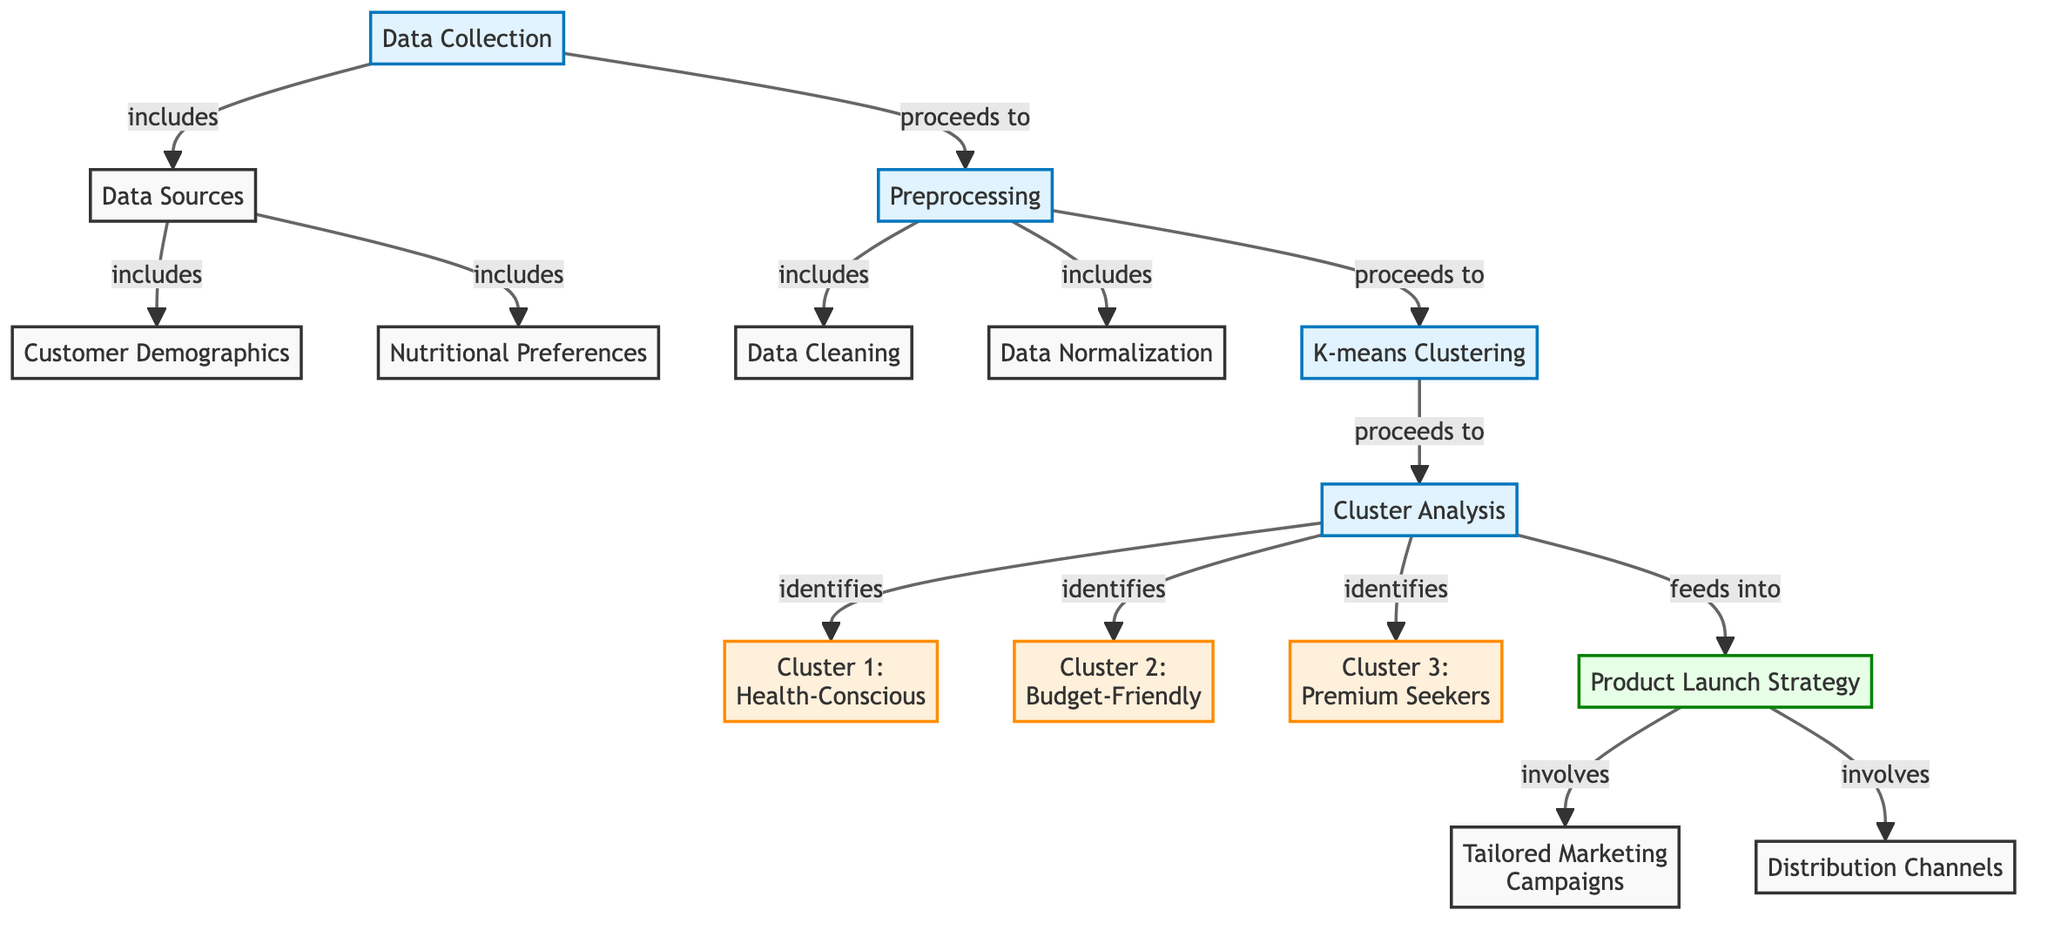What is the initial step in the process? The initial step in the process as represented in the diagram is "Data Collection." This is indicated by the first node in the flowchart and serves as the starting point for the analysis.
Answer: Data Collection How many clusters are identified in the cluster analysis? The diagram indicates three clusters identified during the cluster analysis: Cluster 1, Cluster 2, and Cluster 3. This is summarized in the nodes connected to the cluster analysis step.
Answer: 3 What is the outcome of k-means clustering? The outcome of k-means clustering is "Cluster Analysis." This is shown as the next step that follows k-means clustering in the flowchart.
Answer: Cluster Analysis Which cluster is categorized as 'Premium Seekers'? "Cluster 3" is categorized as 'Premium Seekers' according to the labeled node in the diagram. The node specifically identifies this segment of the market.
Answer: Cluster 3: Premium Seekers What follows the product launch strategy in the diagram? Following the product launch strategy are "Tailored Marketing Campaigns" and "Distribution Channels." These are both shown as subsequent aspects involved in the strategy.
Answer: Tailored Marketing Campaigns, Distribution Channels How is data collected in the initial step? Data is collected from two sources: "Customer Demographics" and "Nutritional Preferences." These sources are indicated as outputs of the data collection process.
Answer: Customer Demographics, Nutritional Preferences What are the two types of data preprocessing listed? The two types of data preprocessing identified in the diagram are "Data Cleaning" and "Normalization." These are represented as steps within the preprocessing node.
Answer: Data Cleaning, Normalization What is the purpose of cluster analysis? The purpose of cluster analysis is to identify distinct customer segments, which results in the identification of the three specific clusters in the flowchart.
Answer: Identify customer segments Which node directly leads to the tailored marketing campaigns? The node that directly leads to "Tailored Marketing Campaigns" is the "Product Launch Strategy." This connection indicates that marketing campaigns are part of the strategy derived from cluster analysis results.
Answer: Product Launch Strategy 